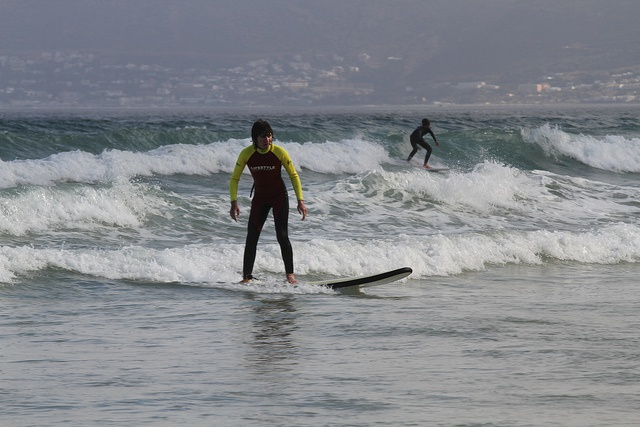Describe the objects in this image and their specific colors. I can see people in gray, black, darkgreen, and darkgray tones, surfboard in gray, darkgray, and black tones, people in gray, black, and purple tones, and surfboard in gray tones in this image. 